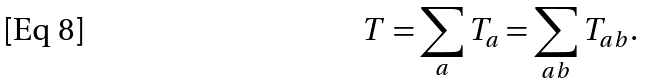<formula> <loc_0><loc_0><loc_500><loc_500>T = \sum _ { a } T _ { a } = \sum _ { a b } T _ { a b } .</formula> 